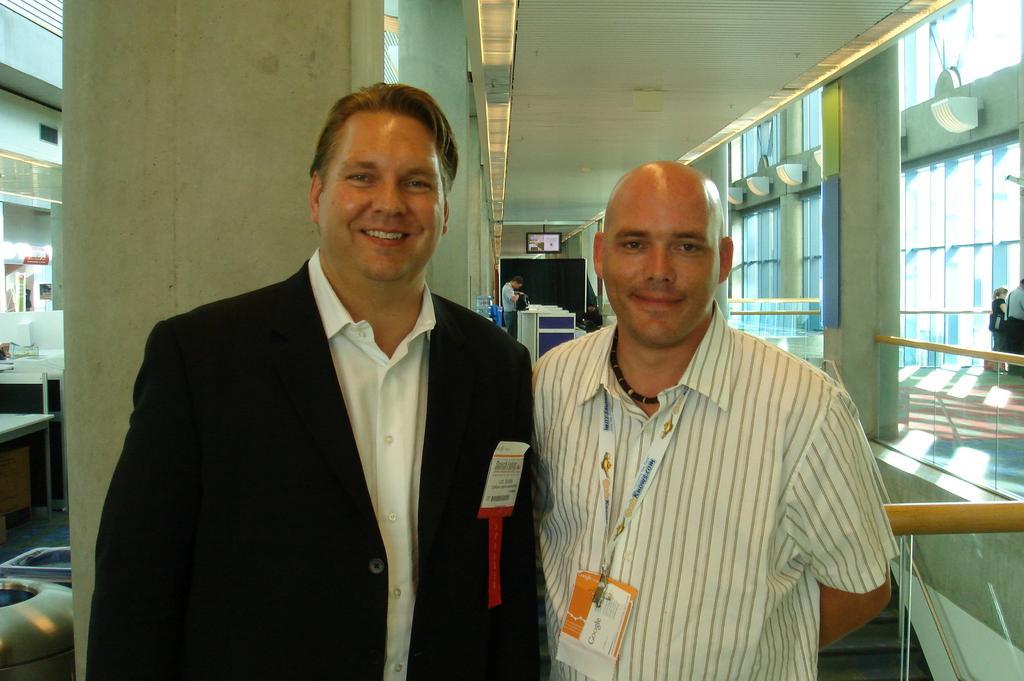How would you summarize this image in a sentence or two? 2 people are standing. The person on the right is wearing an id card. There is another man at the back and there is a screen. Other people are standing on the right. 